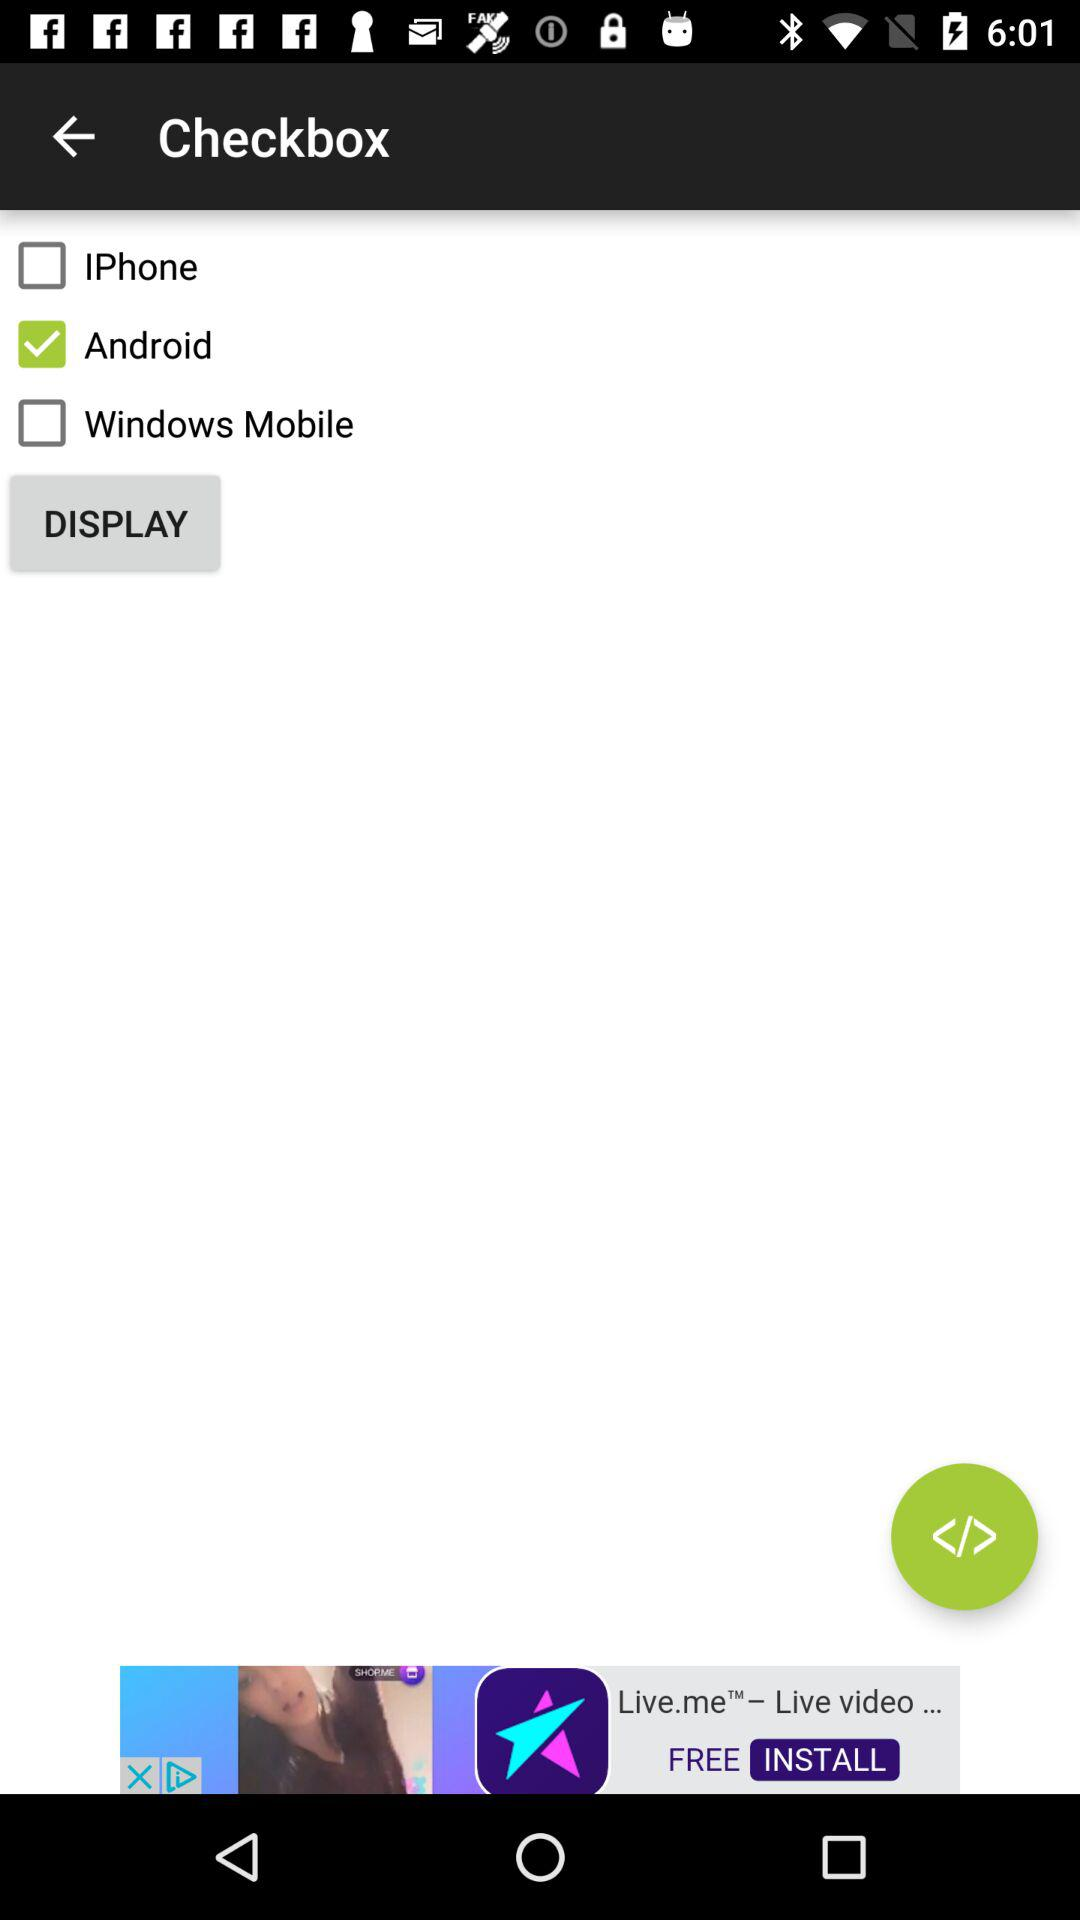How many checkboxes are unchecked? There are two checkboxes that remain unchecked in the image. These are labeled 'IPhone' and 'Windows Mobile'. The only checkbox that is marked with a check is the one next to 'Android'. 